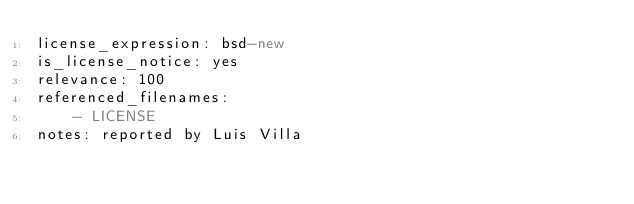<code> <loc_0><loc_0><loc_500><loc_500><_YAML_>license_expression: bsd-new
is_license_notice: yes
relevance: 100
referenced_filenames:
    - LICENSE
notes: reported by Luis Villa
</code> 